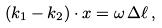<formula> <loc_0><loc_0><loc_500><loc_500>( { k } _ { 1 } - { k } _ { 2 } ) \cdot { x } = \omega \, \Delta \ell \, ,</formula> 